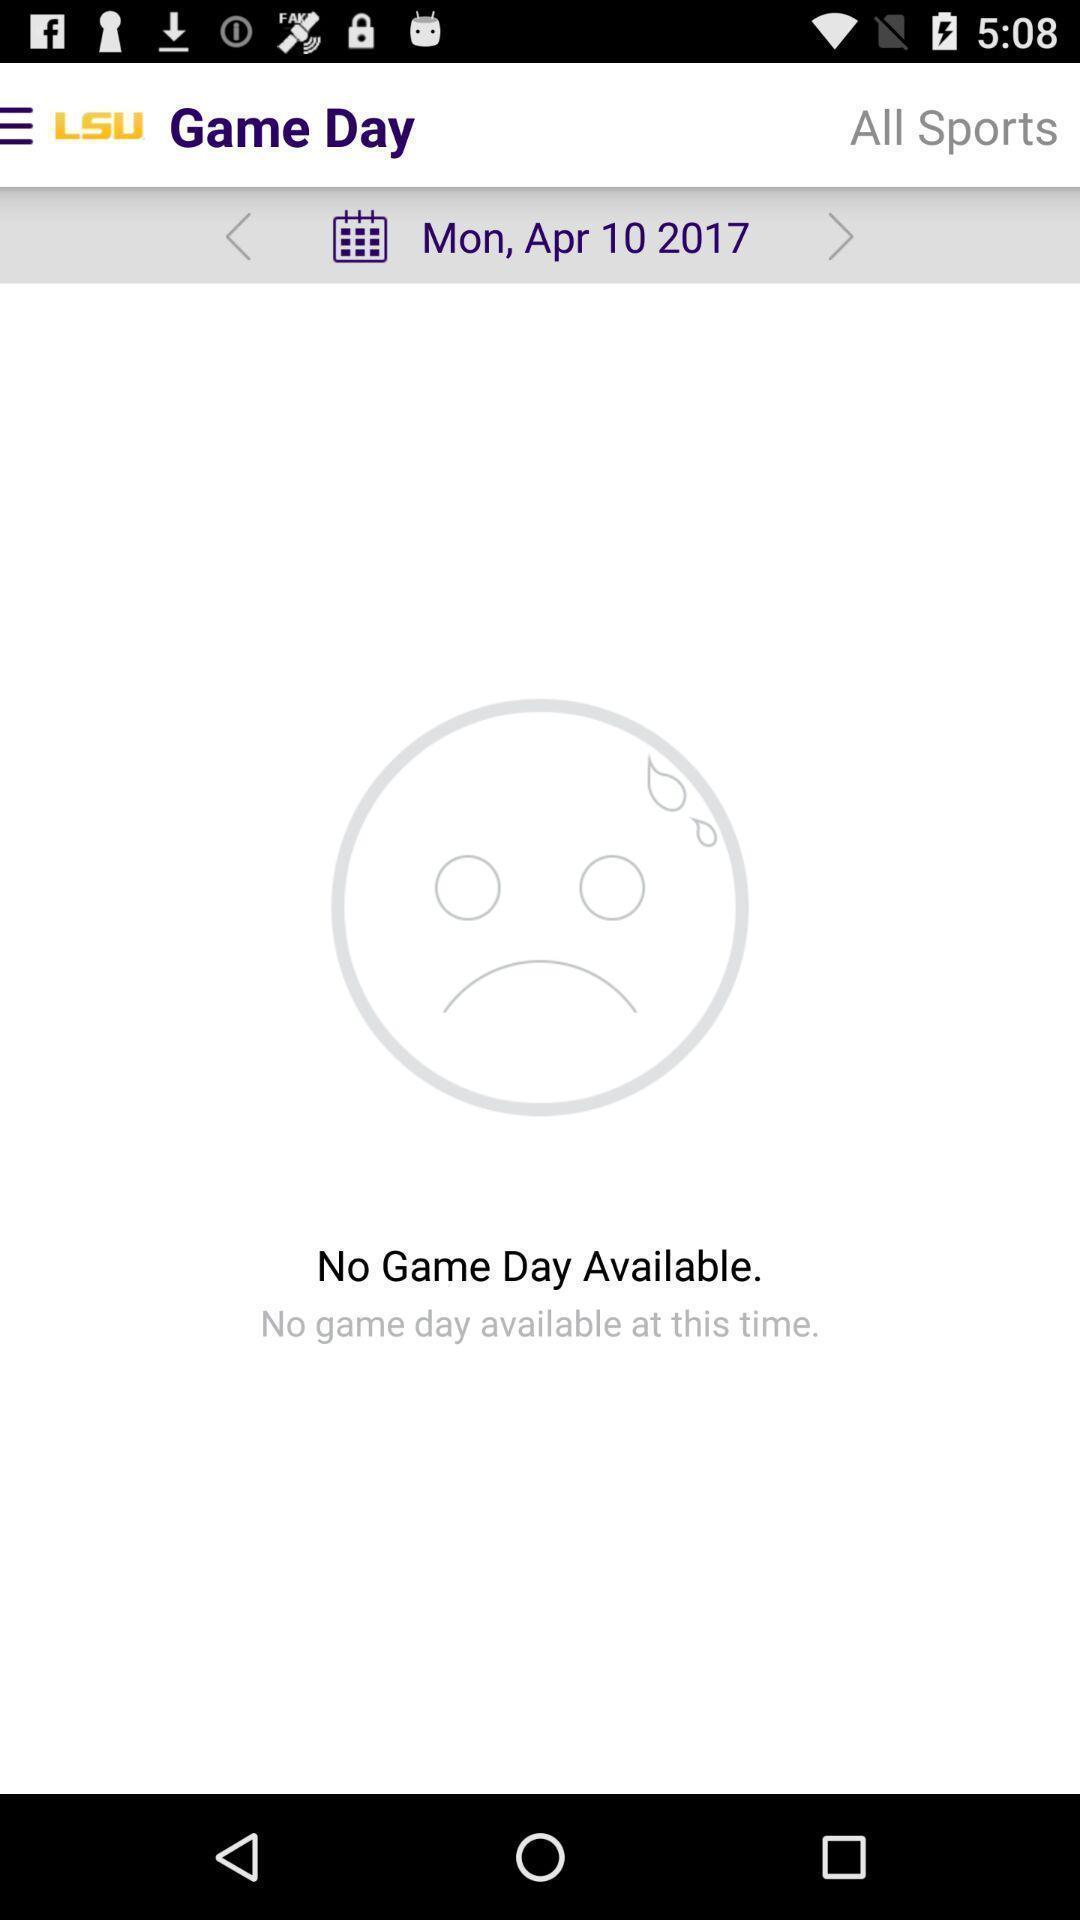Give me a summary of this screen capture. Page displaying the status of sports in gaming application. 